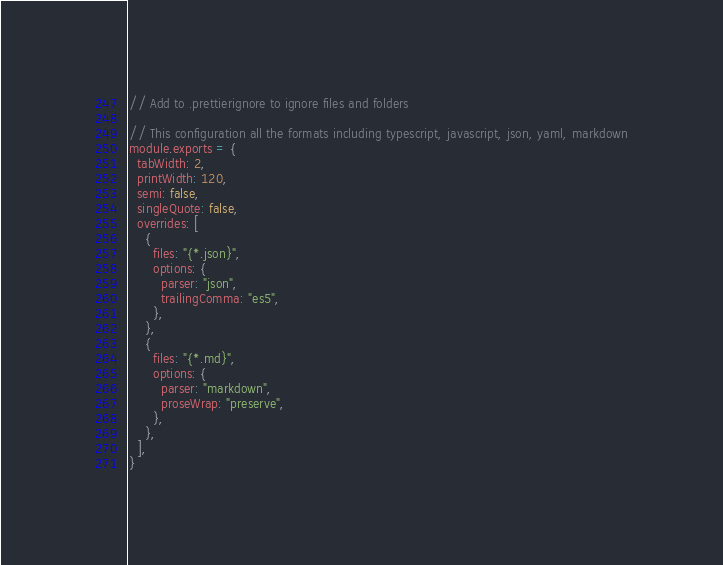<code> <loc_0><loc_0><loc_500><loc_500><_JavaScript_>// Add to .prettierignore to ignore files and folders

// This configuration all the formats including typescript, javascript, json, yaml, markdown
module.exports = {
  tabWidth: 2,
  printWidth: 120,
  semi: false,
  singleQuote: false,
  overrides: [
    {
      files: "{*.json}",
      options: {
        parser: "json",
        trailingComma: "es5",
      },
    },
    {
      files: "{*.md}",
      options: {
        parser: "markdown",
        proseWrap: "preserve",
      },
    },
  ],
}
</code> 